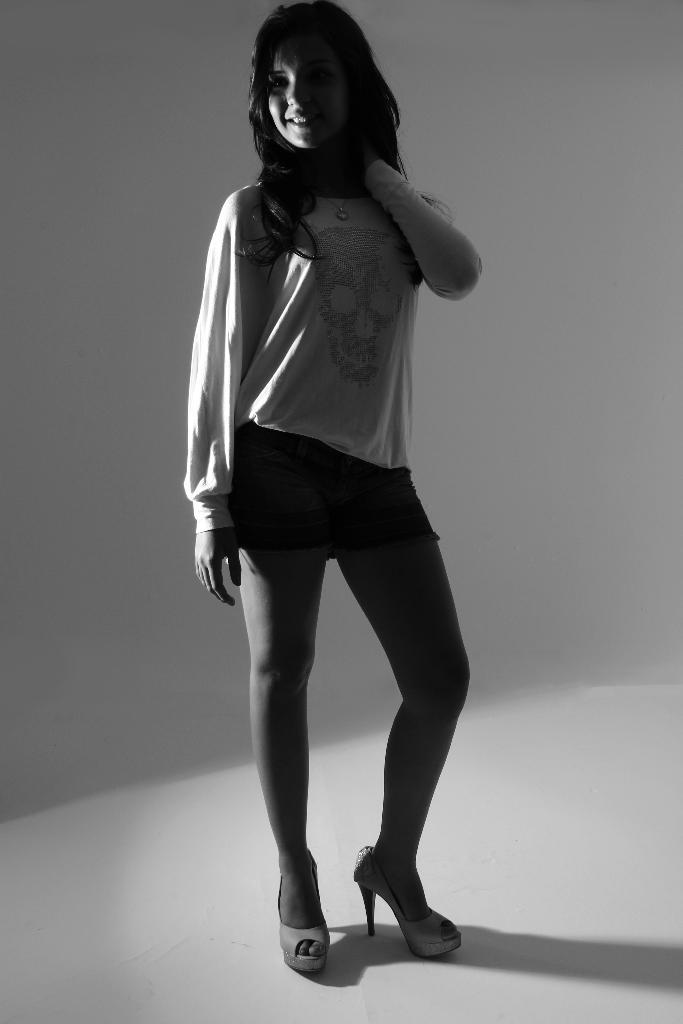What is the color scheme of the image? The image is black and white. Who is present in the image? There is a woman in the image. Where is the woman located in the image? The woman is standing in the middle of the image. What is the woman wearing in the image? The woman is wearing a T-shirt. What is the woman's facial expression in the image? The woman is smiling. How many kittens are sitting on the bread in the image? There are no kittens or bread present in the image. Can you describe the ant's behavior in the image? There is no ant present in the image. 